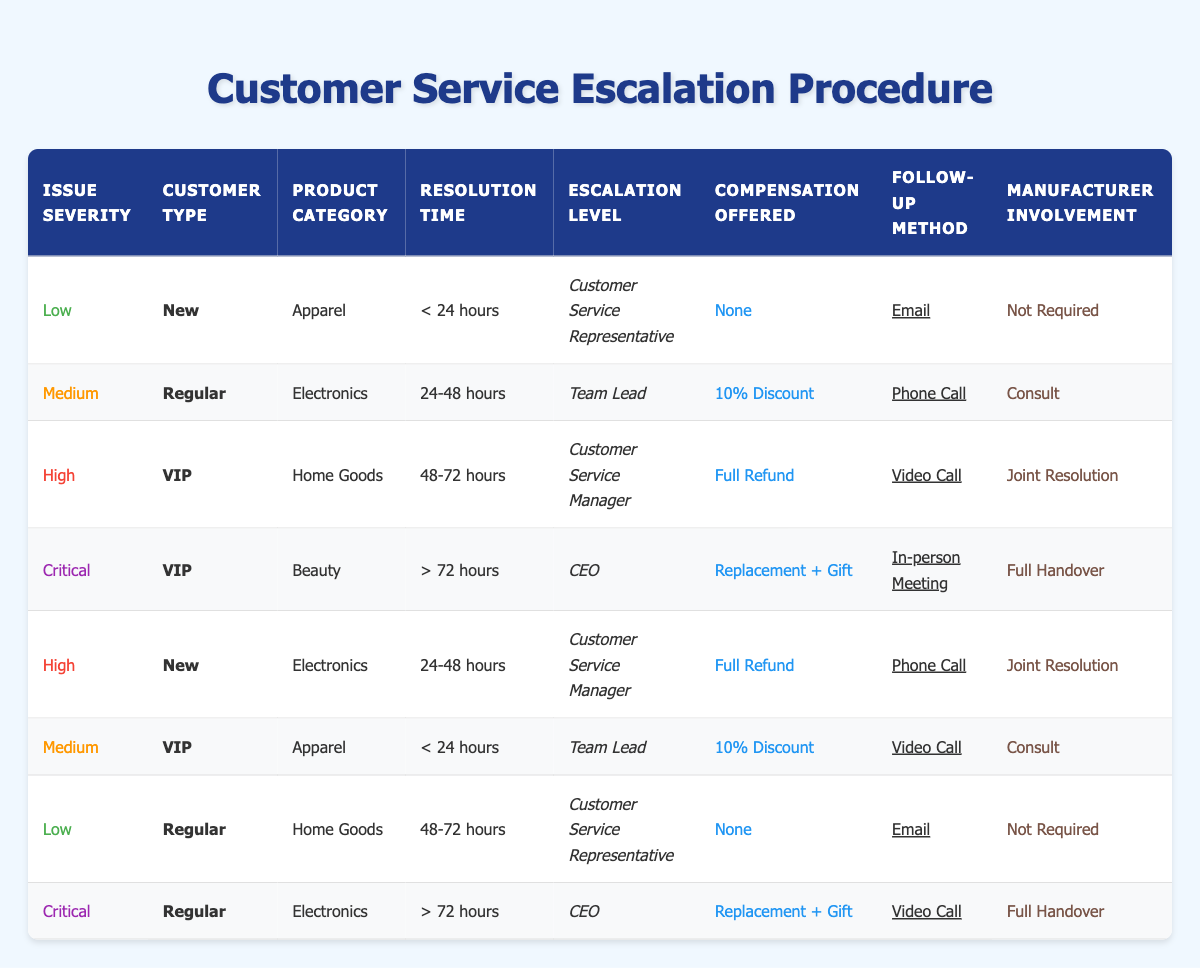What escalation level is required for a critical issue involving a VIP customer in the Beauty category? Referring to the table, under the conditions of 'Critical', 'VIP', and 'Beauty', the escalation level indicated is 'CEO'.
Answer: CEO What compensation is offered for medium severity issues for regular customers in the Electronics category with a resolution time of 24-48 hours? The table shows that for 'Medium' severity, 'Regular' customers, 'Electronics', and resolution time of '24-48 hours', a '10% Discount' is offered as compensation.
Answer: 10% Discount Are in-person meetings required for all critical customer service issues? Reviewing the table, in-person meetings are only required for one specific case: a critical issue for a VIP customer in the Beauty category. Thus, it is not true for all critical issues.
Answer: No How many different follow-up methods are proposed for high-severity issues involving new customers? There are two distinct follow-up methods for high-severity issues with new customers: 'Phone Call' (for Electronics) and another entry for low severity with no follow-up specified; thus, it's just one method applicable for high-severity cases.
Answer: 1 For low-severity issues involving regular customers in the Home Goods category, what escalation level is necessary? According to the table, for 'Low' severity, 'Regular' customers, and 'Home Goods', the action states that the escalation level is 'Customer Service Representative'.
Answer: Customer Service Representative What is the average resolution time for critical issues involving VIP customers? Analyzing only critical issues involving VIP customers, the resolution times are '> 72 hours' (for Beauty) and '> 72 hours' (for Regular); thus, only one distinct resolution time is present as they are the same, resulting in an average of '> 72 hours'.
Answer: > 72 hours Is it true that no manufacturer involvement is required for all low-severity issues? The table shows that for low-severity issues involving new customers in Apparel and regular customers in Home Goods, manufacturer involvement is indeed marked as 'Not Required', thus making the statement true for these examples, but not for all low-severity cases.
Answer: No What is the required follow-up method for high-severity issues in the Home Goods category for VIP customers? The table indicates that for 'High' severity issues, 'VIP' customers, and 'Home Goods', the follow-up method is 'Video Call'.
Answer: Video Call Which compensation is offered for low severity issues involving new customers in the Apparel category? Referring to the 'Low' severity row for new customers in the Apparel category, the compensation offered is 'None'.
Answer: None 